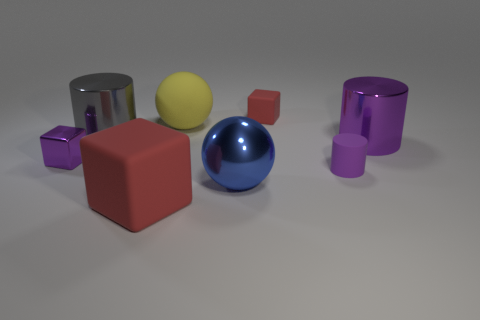Add 1 cyan cylinders. How many objects exist? 9 Subtract all purple cubes. How many cubes are left? 2 Subtract all gray spheres. How many purple cylinders are left? 2 Subtract all blocks. How many objects are left? 5 Add 4 big matte spheres. How many big matte spheres exist? 5 Subtract all yellow balls. How many balls are left? 1 Subtract 0 red cylinders. How many objects are left? 8 Subtract 1 cylinders. How many cylinders are left? 2 Subtract all cyan spheres. Subtract all purple blocks. How many spheres are left? 2 Subtract all matte objects. Subtract all purple rubber cylinders. How many objects are left? 3 